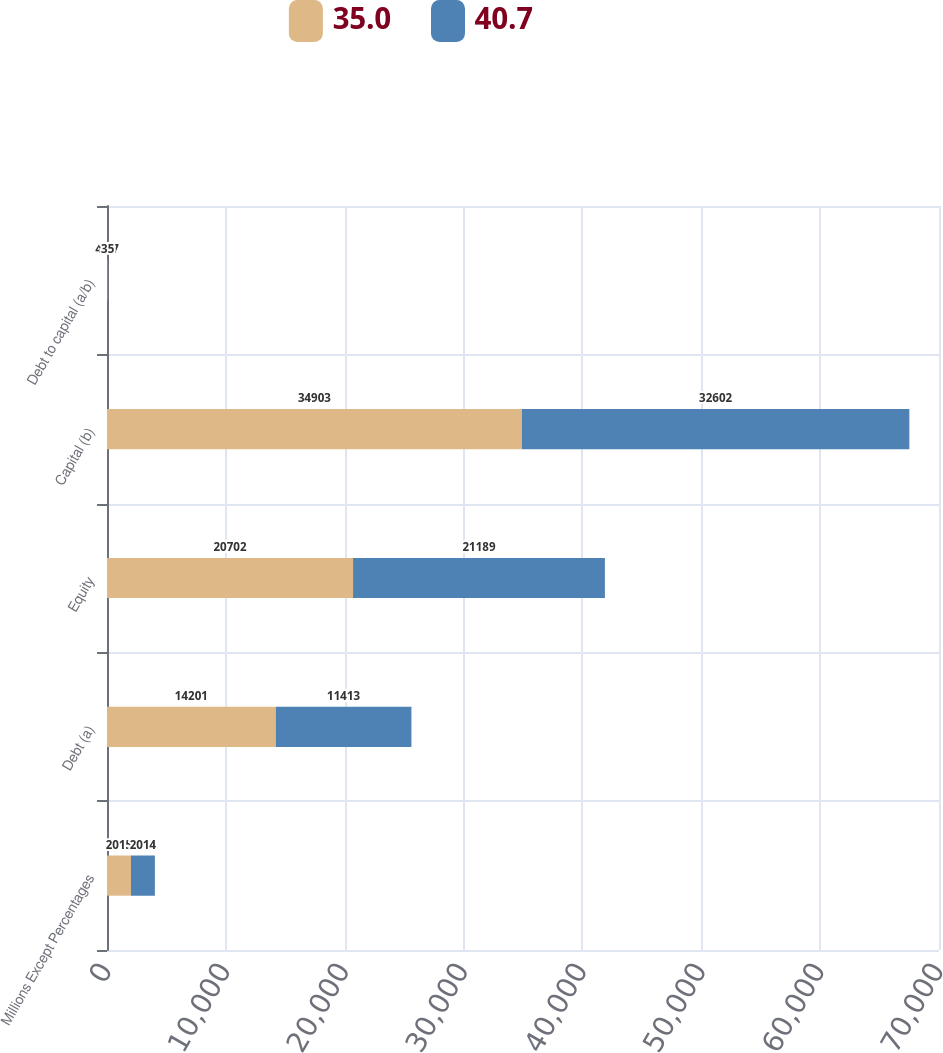<chart> <loc_0><loc_0><loc_500><loc_500><stacked_bar_chart><ecel><fcel>Millions Except Percentages<fcel>Debt (a)<fcel>Equity<fcel>Capital (b)<fcel>Debt to capital (a/b)<nl><fcel>35<fcel>2015<fcel>14201<fcel>20702<fcel>34903<fcel>40.7<nl><fcel>40.7<fcel>2014<fcel>11413<fcel>21189<fcel>32602<fcel>35<nl></chart> 